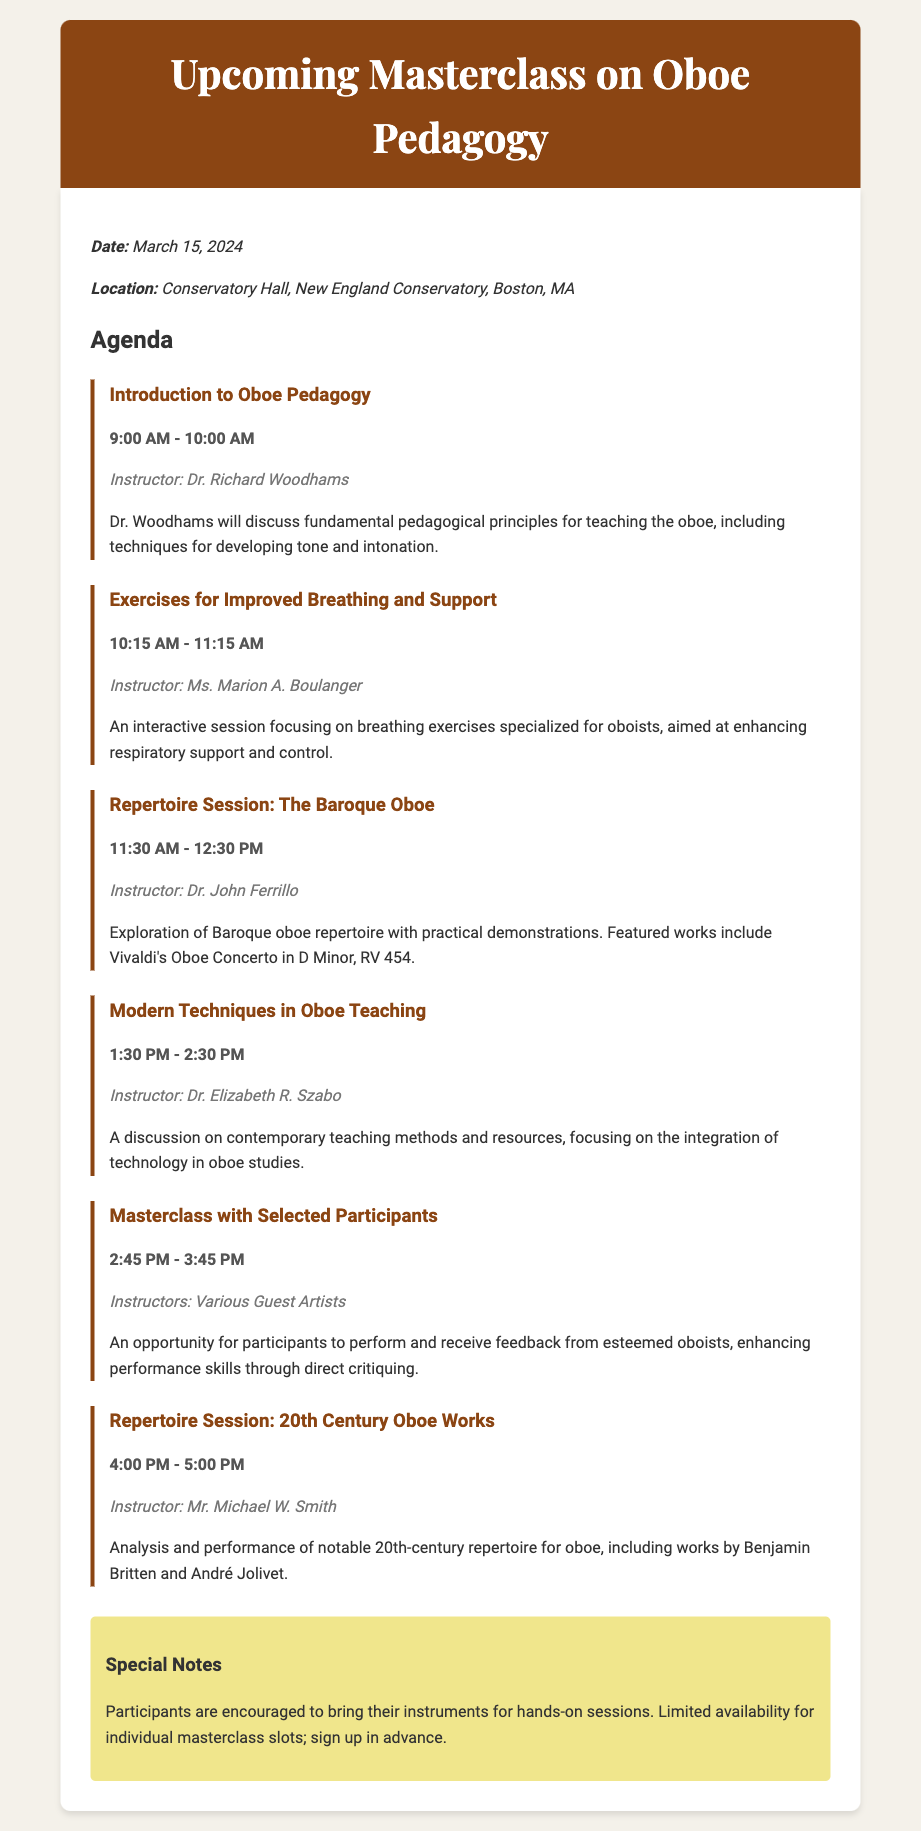What is the date of the masterclass? The date of the masterclass is explicitly stated in the memo's details section, which is March 15, 2024.
Answer: March 15, 2024 Where is the masterclass being held? The location for the masterclass is provided in the memo, which is Conservatory Hall, New England Conservatory, Boston, MA.
Answer: Conservatory Hall, New England Conservatory, Boston, MA Who is the instructor for the "Introduction to Oboe Pedagogy" session? The instructor's name is mentioned in conjunction with this specific session in the agenda, which is Dr. Richard Woodhams.
Answer: Dr. Richard Woodhams What is the first agenda item time slot? The time slot for the first agenda item is indicated clearly in the document, which is from 9:00 AM to 10:00 AM.
Answer: 9:00 AM - 10:00 AM Which oboe concerto is featured in the "Repertoire Session: The Baroque Oboe"? The featured work is explicitly provided in the description of the session, identifying Vivaldi's Oboe Concerto in D Minor, RV 454.
Answer: Vivaldi's Oboe Concerto in D Minor, RV 454 How many instructors will provide feedback during the "Masterclass with Selected Participants"? The memo indicates that various guest artists will be involved, which implies more than one instructor will provide feedback.
Answer: Various Guest Artists What kind of exercises will be focused on during the second session? The memo specifically mentions the focus on breathing exercises in the second session, aimed at oboists.
Answer: Breathing exercises What should participants bring for hands-on sessions? The special notes section explicitly encourages participants to bring their instruments for the practical sessions.
Answer: Instruments 